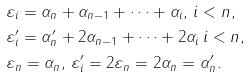Convert formula to latex. <formula><loc_0><loc_0><loc_500><loc_500>& \varepsilon _ { i } = \alpha _ { n } + \alpha _ { n - 1 } + \dots + \alpha _ { i } , \, i < n , \\ & \varepsilon ^ { \prime } _ { i } = \alpha ^ { \prime } _ { n } + 2 \alpha _ { n - 1 } + \dots + 2 \alpha _ { i } \, i < n , \\ & \varepsilon _ { n } = \alpha _ { n } , \, \varepsilon ^ { \prime } _ { i } = 2 \varepsilon _ { n } = 2 \alpha _ { n } = \alpha ^ { \prime } _ { n } .</formula> 